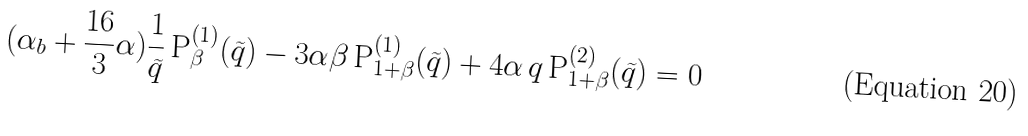Convert formula to latex. <formula><loc_0><loc_0><loc_500><loc_500>( \alpha _ { b } + \frac { 1 6 } { 3 } \alpha ) \frac { 1 } { \widetilde { q } } \, \text {P} ^ { ( 1 ) } _ { \beta } ( \widetilde { q } ) - 3 \alpha \beta \, \text {P} ^ { ( 1 ) } _ { 1 + \beta } ( \widetilde { q } ) + 4 \alpha \, q \, \text {P} ^ { ( 2 ) } _ { 1 + \beta } ( \widetilde { q } ) = 0</formula> 